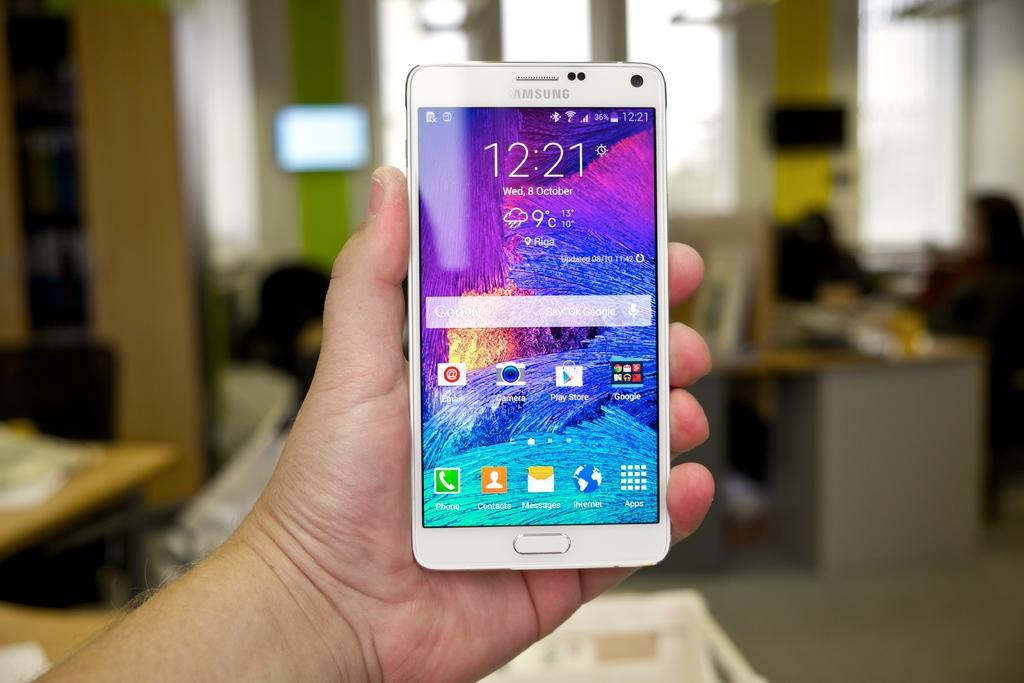Who is present in the image? There is a person in the image. What is the person holding in the image? The person is holding a smartphone. What can be seen on the smartphone screen? There are icons visible on the smartphone screen. Can you describe the background of the image? The background of the image is blurred. What type of caption is the person writing about the volleyball game in the image? There is no volleyball game or caption present in the image. 